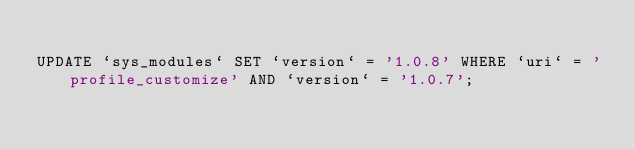<code> <loc_0><loc_0><loc_500><loc_500><_SQL_>
UPDATE `sys_modules` SET `version` = '1.0.8' WHERE `uri` = 'profile_customize' AND `version` = '1.0.7';

</code> 